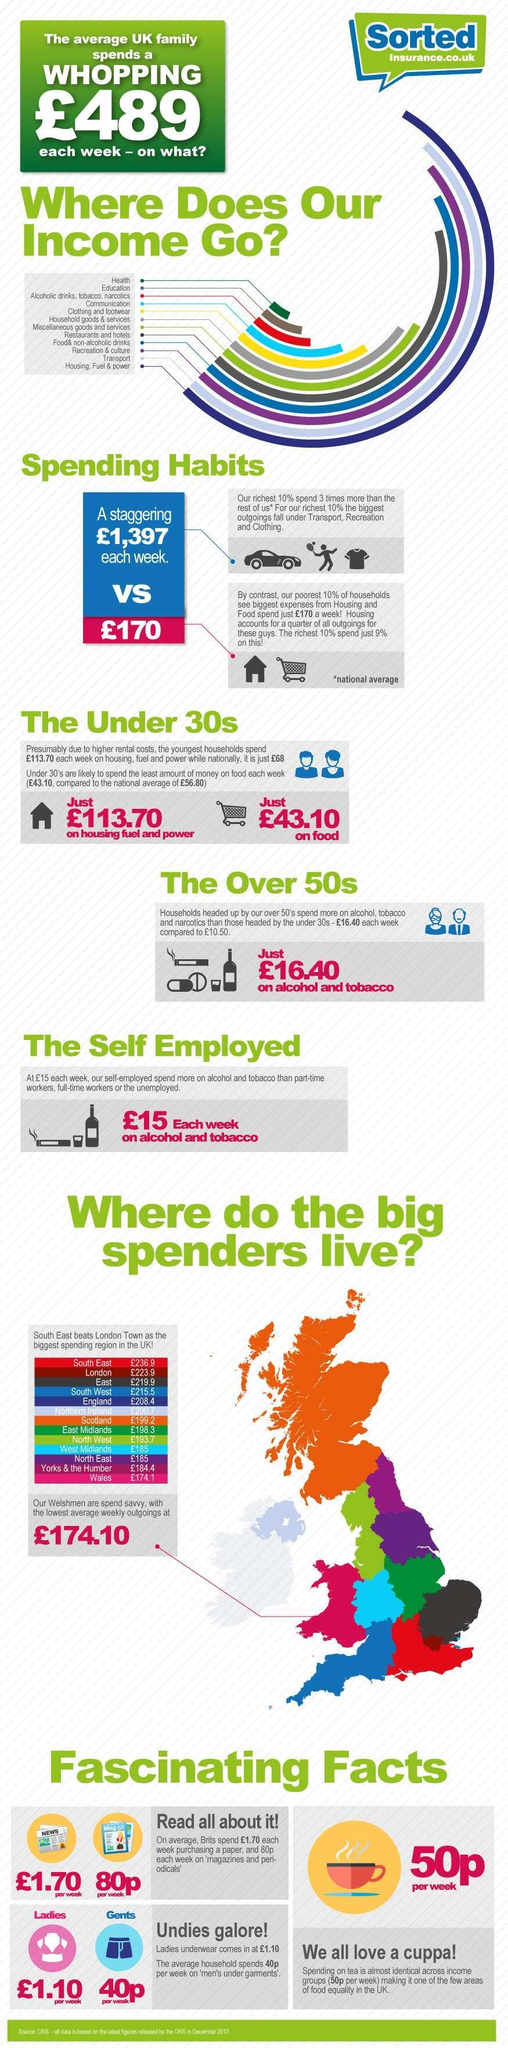What do an average UK family spend on second least each week?
Answer the question with a short phrase. education What do an average UK family spend on the most each week? Housing,Fuel,power Which region in UK has the highest average weekly outgoings? South east Which region in UK has the lowest average weekly outgoings? Wales Which region in UK has the seventh highest average weekly outgoings? Scotland Which region in UK has the fourth highest average weekly outgoings? South west What do the richest 10% spend on the most each week? Transport,recreation,clothing Which region in UK has the second lowest average weekly outgoings? Yorks & the Humber How much do the richest 10% spend each week? £1,397 How much do the poorest 10% spend each week? £170 How much more than the national average do the youngest households pay for housing, fuel and power? £45.70 How much do the richest 10% spend on housing each week? 9% What do the poorest 10% spend on the most each week? housing,food Which region in UK has the third lowest average weekly outgoings? North east Which region in UK has the Third highest average weekly outgoings? East What do an average UK family spend on third most each week? recreation,culture What is the national average of expenditure for housing, fuel and power? £68 What do an average UK family spend on the least each week? health 